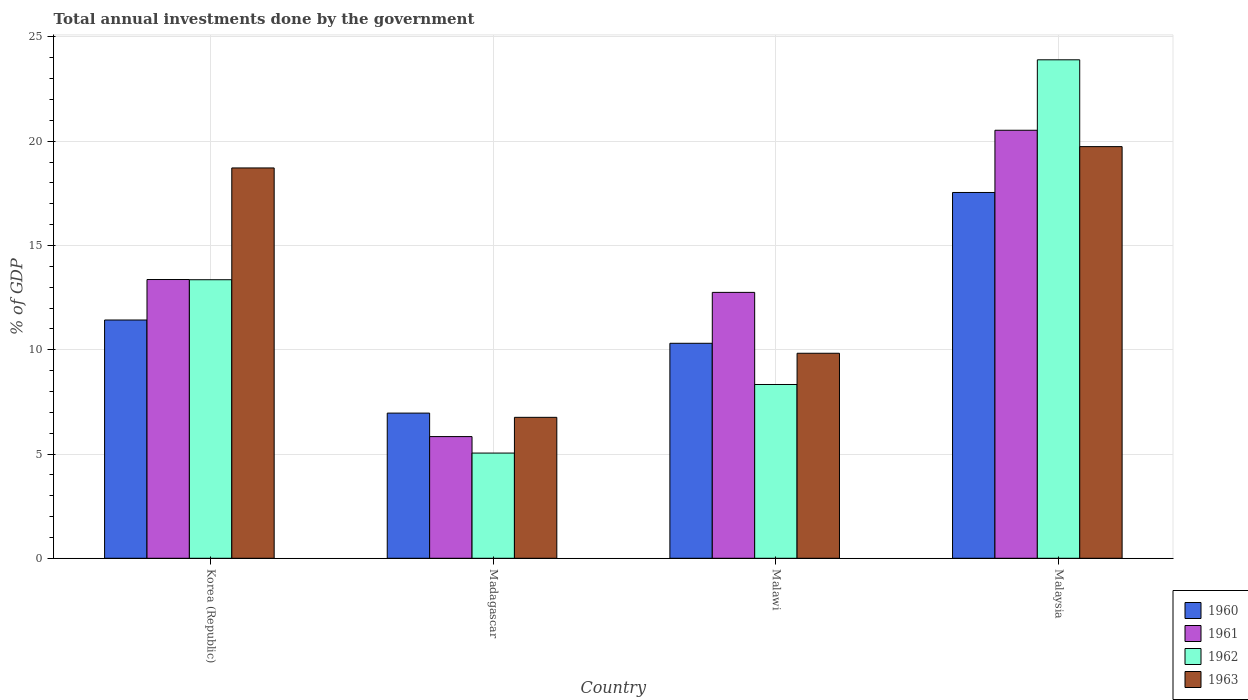How many different coloured bars are there?
Offer a terse response. 4. How many groups of bars are there?
Your answer should be compact. 4. Are the number of bars per tick equal to the number of legend labels?
Your response must be concise. Yes. How many bars are there on the 3rd tick from the left?
Your answer should be compact. 4. What is the label of the 2nd group of bars from the left?
Keep it short and to the point. Madagascar. What is the total annual investments done by the government in 1961 in Korea (Republic)?
Make the answer very short. 13.37. Across all countries, what is the maximum total annual investments done by the government in 1960?
Your response must be concise. 17.54. Across all countries, what is the minimum total annual investments done by the government in 1960?
Your response must be concise. 6.96. In which country was the total annual investments done by the government in 1963 maximum?
Ensure brevity in your answer.  Malaysia. In which country was the total annual investments done by the government in 1962 minimum?
Your answer should be compact. Madagascar. What is the total total annual investments done by the government in 1962 in the graph?
Make the answer very short. 50.64. What is the difference between the total annual investments done by the government in 1963 in Madagascar and that in Malaysia?
Offer a terse response. -12.98. What is the difference between the total annual investments done by the government in 1961 in Malaysia and the total annual investments done by the government in 1962 in Malawi?
Keep it short and to the point. 12.19. What is the average total annual investments done by the government in 1962 per country?
Ensure brevity in your answer.  12.66. What is the difference between the total annual investments done by the government of/in 1962 and total annual investments done by the government of/in 1963 in Malawi?
Keep it short and to the point. -1.5. In how many countries, is the total annual investments done by the government in 1963 greater than 6 %?
Your answer should be very brief. 4. What is the ratio of the total annual investments done by the government in 1963 in Korea (Republic) to that in Malaysia?
Your answer should be very brief. 0.95. What is the difference between the highest and the second highest total annual investments done by the government in 1963?
Give a very brief answer. -8.89. What is the difference between the highest and the lowest total annual investments done by the government in 1960?
Provide a succinct answer. 10.58. In how many countries, is the total annual investments done by the government in 1961 greater than the average total annual investments done by the government in 1961 taken over all countries?
Provide a short and direct response. 2. Is the sum of the total annual investments done by the government in 1963 in Korea (Republic) and Malawi greater than the maximum total annual investments done by the government in 1962 across all countries?
Make the answer very short. Yes. What does the 3rd bar from the right in Malawi represents?
Provide a short and direct response. 1961. Is it the case that in every country, the sum of the total annual investments done by the government in 1963 and total annual investments done by the government in 1960 is greater than the total annual investments done by the government in 1961?
Make the answer very short. Yes. How many countries are there in the graph?
Offer a terse response. 4. Are the values on the major ticks of Y-axis written in scientific E-notation?
Give a very brief answer. No. Does the graph contain grids?
Make the answer very short. Yes. Where does the legend appear in the graph?
Ensure brevity in your answer.  Bottom right. How are the legend labels stacked?
Your answer should be compact. Vertical. What is the title of the graph?
Your response must be concise. Total annual investments done by the government. Does "1963" appear as one of the legend labels in the graph?
Your answer should be compact. Yes. What is the label or title of the X-axis?
Ensure brevity in your answer.  Country. What is the label or title of the Y-axis?
Provide a short and direct response. % of GDP. What is the % of GDP in 1960 in Korea (Republic)?
Your answer should be very brief. 11.43. What is the % of GDP of 1961 in Korea (Republic)?
Your response must be concise. 13.37. What is the % of GDP in 1962 in Korea (Republic)?
Offer a very short reply. 13.36. What is the % of GDP in 1963 in Korea (Republic)?
Make the answer very short. 18.72. What is the % of GDP in 1960 in Madagascar?
Offer a very short reply. 6.96. What is the % of GDP in 1961 in Madagascar?
Provide a short and direct response. 5.84. What is the % of GDP of 1962 in Madagascar?
Provide a short and direct response. 5.04. What is the % of GDP in 1963 in Madagascar?
Your answer should be compact. 6.76. What is the % of GDP of 1960 in Malawi?
Offer a terse response. 10.31. What is the % of GDP of 1961 in Malawi?
Keep it short and to the point. 12.75. What is the % of GDP in 1962 in Malawi?
Offer a terse response. 8.33. What is the % of GDP in 1963 in Malawi?
Make the answer very short. 9.83. What is the % of GDP in 1960 in Malaysia?
Give a very brief answer. 17.54. What is the % of GDP in 1961 in Malaysia?
Your answer should be very brief. 20.52. What is the % of GDP in 1962 in Malaysia?
Your answer should be very brief. 23.9. What is the % of GDP in 1963 in Malaysia?
Make the answer very short. 19.74. Across all countries, what is the maximum % of GDP in 1960?
Keep it short and to the point. 17.54. Across all countries, what is the maximum % of GDP of 1961?
Make the answer very short. 20.52. Across all countries, what is the maximum % of GDP in 1962?
Provide a succinct answer. 23.9. Across all countries, what is the maximum % of GDP in 1963?
Your answer should be very brief. 19.74. Across all countries, what is the minimum % of GDP of 1960?
Offer a very short reply. 6.96. Across all countries, what is the minimum % of GDP in 1961?
Make the answer very short. 5.84. Across all countries, what is the minimum % of GDP in 1962?
Provide a short and direct response. 5.04. Across all countries, what is the minimum % of GDP in 1963?
Your answer should be very brief. 6.76. What is the total % of GDP in 1960 in the graph?
Offer a terse response. 46.24. What is the total % of GDP of 1961 in the graph?
Provide a short and direct response. 52.48. What is the total % of GDP in 1962 in the graph?
Give a very brief answer. 50.64. What is the total % of GDP in 1963 in the graph?
Your answer should be compact. 55.05. What is the difference between the % of GDP of 1960 in Korea (Republic) and that in Madagascar?
Offer a very short reply. 4.46. What is the difference between the % of GDP of 1961 in Korea (Republic) and that in Madagascar?
Offer a terse response. 7.53. What is the difference between the % of GDP of 1962 in Korea (Republic) and that in Madagascar?
Make the answer very short. 8.31. What is the difference between the % of GDP of 1963 in Korea (Republic) and that in Madagascar?
Make the answer very short. 11.96. What is the difference between the % of GDP in 1960 in Korea (Republic) and that in Malawi?
Your answer should be very brief. 1.12. What is the difference between the % of GDP in 1961 in Korea (Republic) and that in Malawi?
Give a very brief answer. 0.62. What is the difference between the % of GDP of 1962 in Korea (Republic) and that in Malawi?
Keep it short and to the point. 5.02. What is the difference between the % of GDP of 1963 in Korea (Republic) and that in Malawi?
Provide a succinct answer. 8.89. What is the difference between the % of GDP of 1960 in Korea (Republic) and that in Malaysia?
Ensure brevity in your answer.  -6.12. What is the difference between the % of GDP in 1961 in Korea (Republic) and that in Malaysia?
Offer a terse response. -7.16. What is the difference between the % of GDP in 1962 in Korea (Republic) and that in Malaysia?
Give a very brief answer. -10.55. What is the difference between the % of GDP in 1963 in Korea (Republic) and that in Malaysia?
Provide a short and direct response. -1.02. What is the difference between the % of GDP of 1960 in Madagascar and that in Malawi?
Give a very brief answer. -3.35. What is the difference between the % of GDP of 1961 in Madagascar and that in Malawi?
Give a very brief answer. -6.92. What is the difference between the % of GDP of 1962 in Madagascar and that in Malawi?
Your answer should be compact. -3.29. What is the difference between the % of GDP of 1963 in Madagascar and that in Malawi?
Offer a terse response. -3.07. What is the difference between the % of GDP of 1960 in Madagascar and that in Malaysia?
Give a very brief answer. -10.58. What is the difference between the % of GDP in 1961 in Madagascar and that in Malaysia?
Give a very brief answer. -14.69. What is the difference between the % of GDP in 1962 in Madagascar and that in Malaysia?
Offer a very short reply. -18.86. What is the difference between the % of GDP of 1963 in Madagascar and that in Malaysia?
Your answer should be very brief. -12.98. What is the difference between the % of GDP of 1960 in Malawi and that in Malaysia?
Provide a succinct answer. -7.23. What is the difference between the % of GDP of 1961 in Malawi and that in Malaysia?
Offer a terse response. -7.77. What is the difference between the % of GDP of 1962 in Malawi and that in Malaysia?
Offer a very short reply. -15.57. What is the difference between the % of GDP of 1963 in Malawi and that in Malaysia?
Give a very brief answer. -9.91. What is the difference between the % of GDP of 1960 in Korea (Republic) and the % of GDP of 1961 in Madagascar?
Provide a short and direct response. 5.59. What is the difference between the % of GDP of 1960 in Korea (Republic) and the % of GDP of 1962 in Madagascar?
Offer a terse response. 6.38. What is the difference between the % of GDP in 1960 in Korea (Republic) and the % of GDP in 1963 in Madagascar?
Ensure brevity in your answer.  4.67. What is the difference between the % of GDP of 1961 in Korea (Republic) and the % of GDP of 1962 in Madagascar?
Offer a very short reply. 8.32. What is the difference between the % of GDP of 1961 in Korea (Republic) and the % of GDP of 1963 in Madagascar?
Your answer should be very brief. 6.61. What is the difference between the % of GDP of 1962 in Korea (Republic) and the % of GDP of 1963 in Madagascar?
Your answer should be compact. 6.6. What is the difference between the % of GDP of 1960 in Korea (Republic) and the % of GDP of 1961 in Malawi?
Make the answer very short. -1.33. What is the difference between the % of GDP in 1960 in Korea (Republic) and the % of GDP in 1962 in Malawi?
Make the answer very short. 3.09. What is the difference between the % of GDP of 1960 in Korea (Republic) and the % of GDP of 1963 in Malawi?
Your answer should be very brief. 1.59. What is the difference between the % of GDP in 1961 in Korea (Republic) and the % of GDP in 1962 in Malawi?
Give a very brief answer. 5.03. What is the difference between the % of GDP in 1961 in Korea (Republic) and the % of GDP in 1963 in Malawi?
Provide a short and direct response. 3.54. What is the difference between the % of GDP in 1962 in Korea (Republic) and the % of GDP in 1963 in Malawi?
Keep it short and to the point. 3.53. What is the difference between the % of GDP in 1960 in Korea (Republic) and the % of GDP in 1961 in Malaysia?
Provide a succinct answer. -9.1. What is the difference between the % of GDP in 1960 in Korea (Republic) and the % of GDP in 1962 in Malaysia?
Provide a short and direct response. -12.48. What is the difference between the % of GDP in 1960 in Korea (Republic) and the % of GDP in 1963 in Malaysia?
Make the answer very short. -8.32. What is the difference between the % of GDP in 1961 in Korea (Republic) and the % of GDP in 1962 in Malaysia?
Your answer should be very brief. -10.54. What is the difference between the % of GDP of 1961 in Korea (Republic) and the % of GDP of 1963 in Malaysia?
Offer a terse response. -6.37. What is the difference between the % of GDP of 1962 in Korea (Republic) and the % of GDP of 1963 in Malaysia?
Offer a very short reply. -6.38. What is the difference between the % of GDP of 1960 in Madagascar and the % of GDP of 1961 in Malawi?
Give a very brief answer. -5.79. What is the difference between the % of GDP in 1960 in Madagascar and the % of GDP in 1962 in Malawi?
Your answer should be compact. -1.37. What is the difference between the % of GDP in 1960 in Madagascar and the % of GDP in 1963 in Malawi?
Offer a terse response. -2.87. What is the difference between the % of GDP in 1961 in Madagascar and the % of GDP in 1962 in Malawi?
Provide a succinct answer. -2.5. What is the difference between the % of GDP in 1961 in Madagascar and the % of GDP in 1963 in Malawi?
Provide a short and direct response. -4. What is the difference between the % of GDP in 1962 in Madagascar and the % of GDP in 1963 in Malawi?
Ensure brevity in your answer.  -4.79. What is the difference between the % of GDP in 1960 in Madagascar and the % of GDP in 1961 in Malaysia?
Your response must be concise. -13.56. What is the difference between the % of GDP of 1960 in Madagascar and the % of GDP of 1962 in Malaysia?
Offer a very short reply. -16.94. What is the difference between the % of GDP in 1960 in Madagascar and the % of GDP in 1963 in Malaysia?
Your answer should be compact. -12.78. What is the difference between the % of GDP of 1961 in Madagascar and the % of GDP of 1962 in Malaysia?
Ensure brevity in your answer.  -18.07. What is the difference between the % of GDP of 1961 in Madagascar and the % of GDP of 1963 in Malaysia?
Your answer should be compact. -13.9. What is the difference between the % of GDP in 1962 in Madagascar and the % of GDP in 1963 in Malaysia?
Give a very brief answer. -14.7. What is the difference between the % of GDP in 1960 in Malawi and the % of GDP in 1961 in Malaysia?
Give a very brief answer. -10.22. What is the difference between the % of GDP in 1960 in Malawi and the % of GDP in 1962 in Malaysia?
Provide a short and direct response. -13.59. What is the difference between the % of GDP of 1960 in Malawi and the % of GDP of 1963 in Malaysia?
Provide a short and direct response. -9.43. What is the difference between the % of GDP in 1961 in Malawi and the % of GDP in 1962 in Malaysia?
Provide a short and direct response. -11.15. What is the difference between the % of GDP in 1961 in Malawi and the % of GDP in 1963 in Malaysia?
Make the answer very short. -6.99. What is the difference between the % of GDP of 1962 in Malawi and the % of GDP of 1963 in Malaysia?
Offer a terse response. -11.41. What is the average % of GDP of 1960 per country?
Your answer should be very brief. 11.56. What is the average % of GDP of 1961 per country?
Provide a short and direct response. 13.12. What is the average % of GDP in 1962 per country?
Your answer should be very brief. 12.66. What is the average % of GDP of 1963 per country?
Provide a short and direct response. 13.76. What is the difference between the % of GDP in 1960 and % of GDP in 1961 in Korea (Republic)?
Keep it short and to the point. -1.94. What is the difference between the % of GDP in 1960 and % of GDP in 1962 in Korea (Republic)?
Keep it short and to the point. -1.93. What is the difference between the % of GDP in 1960 and % of GDP in 1963 in Korea (Republic)?
Offer a terse response. -7.29. What is the difference between the % of GDP in 1961 and % of GDP in 1962 in Korea (Republic)?
Ensure brevity in your answer.  0.01. What is the difference between the % of GDP of 1961 and % of GDP of 1963 in Korea (Republic)?
Offer a very short reply. -5.35. What is the difference between the % of GDP in 1962 and % of GDP in 1963 in Korea (Republic)?
Your answer should be very brief. -5.36. What is the difference between the % of GDP of 1960 and % of GDP of 1961 in Madagascar?
Offer a terse response. 1.13. What is the difference between the % of GDP in 1960 and % of GDP in 1962 in Madagascar?
Keep it short and to the point. 1.92. What is the difference between the % of GDP in 1960 and % of GDP in 1963 in Madagascar?
Offer a terse response. 0.2. What is the difference between the % of GDP in 1961 and % of GDP in 1962 in Madagascar?
Offer a terse response. 0.79. What is the difference between the % of GDP in 1961 and % of GDP in 1963 in Madagascar?
Give a very brief answer. -0.92. What is the difference between the % of GDP of 1962 and % of GDP of 1963 in Madagascar?
Ensure brevity in your answer.  -1.71. What is the difference between the % of GDP of 1960 and % of GDP of 1961 in Malawi?
Provide a short and direct response. -2.44. What is the difference between the % of GDP in 1960 and % of GDP in 1962 in Malawi?
Offer a very short reply. 1.98. What is the difference between the % of GDP in 1960 and % of GDP in 1963 in Malawi?
Keep it short and to the point. 0.48. What is the difference between the % of GDP in 1961 and % of GDP in 1962 in Malawi?
Make the answer very short. 4.42. What is the difference between the % of GDP of 1961 and % of GDP of 1963 in Malawi?
Your response must be concise. 2.92. What is the difference between the % of GDP in 1962 and % of GDP in 1963 in Malawi?
Your answer should be very brief. -1.5. What is the difference between the % of GDP in 1960 and % of GDP in 1961 in Malaysia?
Make the answer very short. -2.98. What is the difference between the % of GDP of 1960 and % of GDP of 1962 in Malaysia?
Offer a very short reply. -6.36. What is the difference between the % of GDP of 1960 and % of GDP of 1963 in Malaysia?
Ensure brevity in your answer.  -2.2. What is the difference between the % of GDP of 1961 and % of GDP of 1962 in Malaysia?
Your answer should be very brief. -3.38. What is the difference between the % of GDP in 1961 and % of GDP in 1963 in Malaysia?
Ensure brevity in your answer.  0.78. What is the difference between the % of GDP of 1962 and % of GDP of 1963 in Malaysia?
Your answer should be very brief. 4.16. What is the ratio of the % of GDP of 1960 in Korea (Republic) to that in Madagascar?
Your answer should be very brief. 1.64. What is the ratio of the % of GDP in 1961 in Korea (Republic) to that in Madagascar?
Provide a short and direct response. 2.29. What is the ratio of the % of GDP in 1962 in Korea (Republic) to that in Madagascar?
Give a very brief answer. 2.65. What is the ratio of the % of GDP in 1963 in Korea (Republic) to that in Madagascar?
Your answer should be very brief. 2.77. What is the ratio of the % of GDP of 1960 in Korea (Republic) to that in Malawi?
Offer a terse response. 1.11. What is the ratio of the % of GDP in 1961 in Korea (Republic) to that in Malawi?
Provide a short and direct response. 1.05. What is the ratio of the % of GDP in 1962 in Korea (Republic) to that in Malawi?
Keep it short and to the point. 1.6. What is the ratio of the % of GDP in 1963 in Korea (Republic) to that in Malawi?
Provide a short and direct response. 1.9. What is the ratio of the % of GDP in 1960 in Korea (Republic) to that in Malaysia?
Give a very brief answer. 0.65. What is the ratio of the % of GDP in 1961 in Korea (Republic) to that in Malaysia?
Your answer should be compact. 0.65. What is the ratio of the % of GDP of 1962 in Korea (Republic) to that in Malaysia?
Offer a terse response. 0.56. What is the ratio of the % of GDP in 1963 in Korea (Republic) to that in Malaysia?
Your answer should be compact. 0.95. What is the ratio of the % of GDP in 1960 in Madagascar to that in Malawi?
Your response must be concise. 0.68. What is the ratio of the % of GDP in 1961 in Madagascar to that in Malawi?
Provide a short and direct response. 0.46. What is the ratio of the % of GDP in 1962 in Madagascar to that in Malawi?
Keep it short and to the point. 0.61. What is the ratio of the % of GDP in 1963 in Madagascar to that in Malawi?
Your response must be concise. 0.69. What is the ratio of the % of GDP in 1960 in Madagascar to that in Malaysia?
Give a very brief answer. 0.4. What is the ratio of the % of GDP in 1961 in Madagascar to that in Malaysia?
Give a very brief answer. 0.28. What is the ratio of the % of GDP in 1962 in Madagascar to that in Malaysia?
Offer a very short reply. 0.21. What is the ratio of the % of GDP of 1963 in Madagascar to that in Malaysia?
Provide a succinct answer. 0.34. What is the ratio of the % of GDP of 1960 in Malawi to that in Malaysia?
Offer a very short reply. 0.59. What is the ratio of the % of GDP in 1961 in Malawi to that in Malaysia?
Provide a short and direct response. 0.62. What is the ratio of the % of GDP of 1962 in Malawi to that in Malaysia?
Keep it short and to the point. 0.35. What is the ratio of the % of GDP of 1963 in Malawi to that in Malaysia?
Your answer should be compact. 0.5. What is the difference between the highest and the second highest % of GDP in 1960?
Your answer should be compact. 6.12. What is the difference between the highest and the second highest % of GDP in 1961?
Your response must be concise. 7.16. What is the difference between the highest and the second highest % of GDP of 1962?
Give a very brief answer. 10.55. What is the difference between the highest and the second highest % of GDP in 1963?
Your answer should be compact. 1.02. What is the difference between the highest and the lowest % of GDP of 1960?
Provide a succinct answer. 10.58. What is the difference between the highest and the lowest % of GDP of 1961?
Provide a succinct answer. 14.69. What is the difference between the highest and the lowest % of GDP in 1962?
Offer a very short reply. 18.86. What is the difference between the highest and the lowest % of GDP of 1963?
Keep it short and to the point. 12.98. 